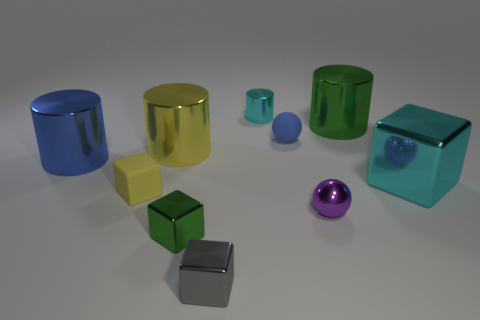Subtract all cylinders. How many objects are left? 6 Add 2 tiny shiny cubes. How many tiny shiny cubes exist? 4 Subtract 0 brown cylinders. How many objects are left? 10 Subtract all small metal cylinders. Subtract all big yellow things. How many objects are left? 8 Add 3 rubber spheres. How many rubber spheres are left? 4 